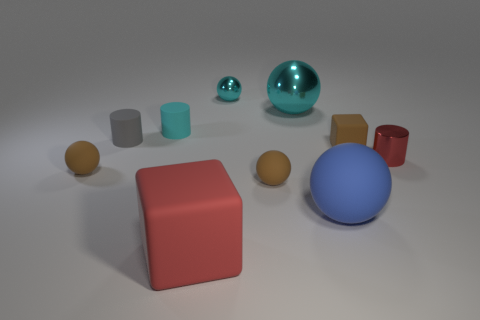What color is the big matte thing that is left of the large blue ball? red 